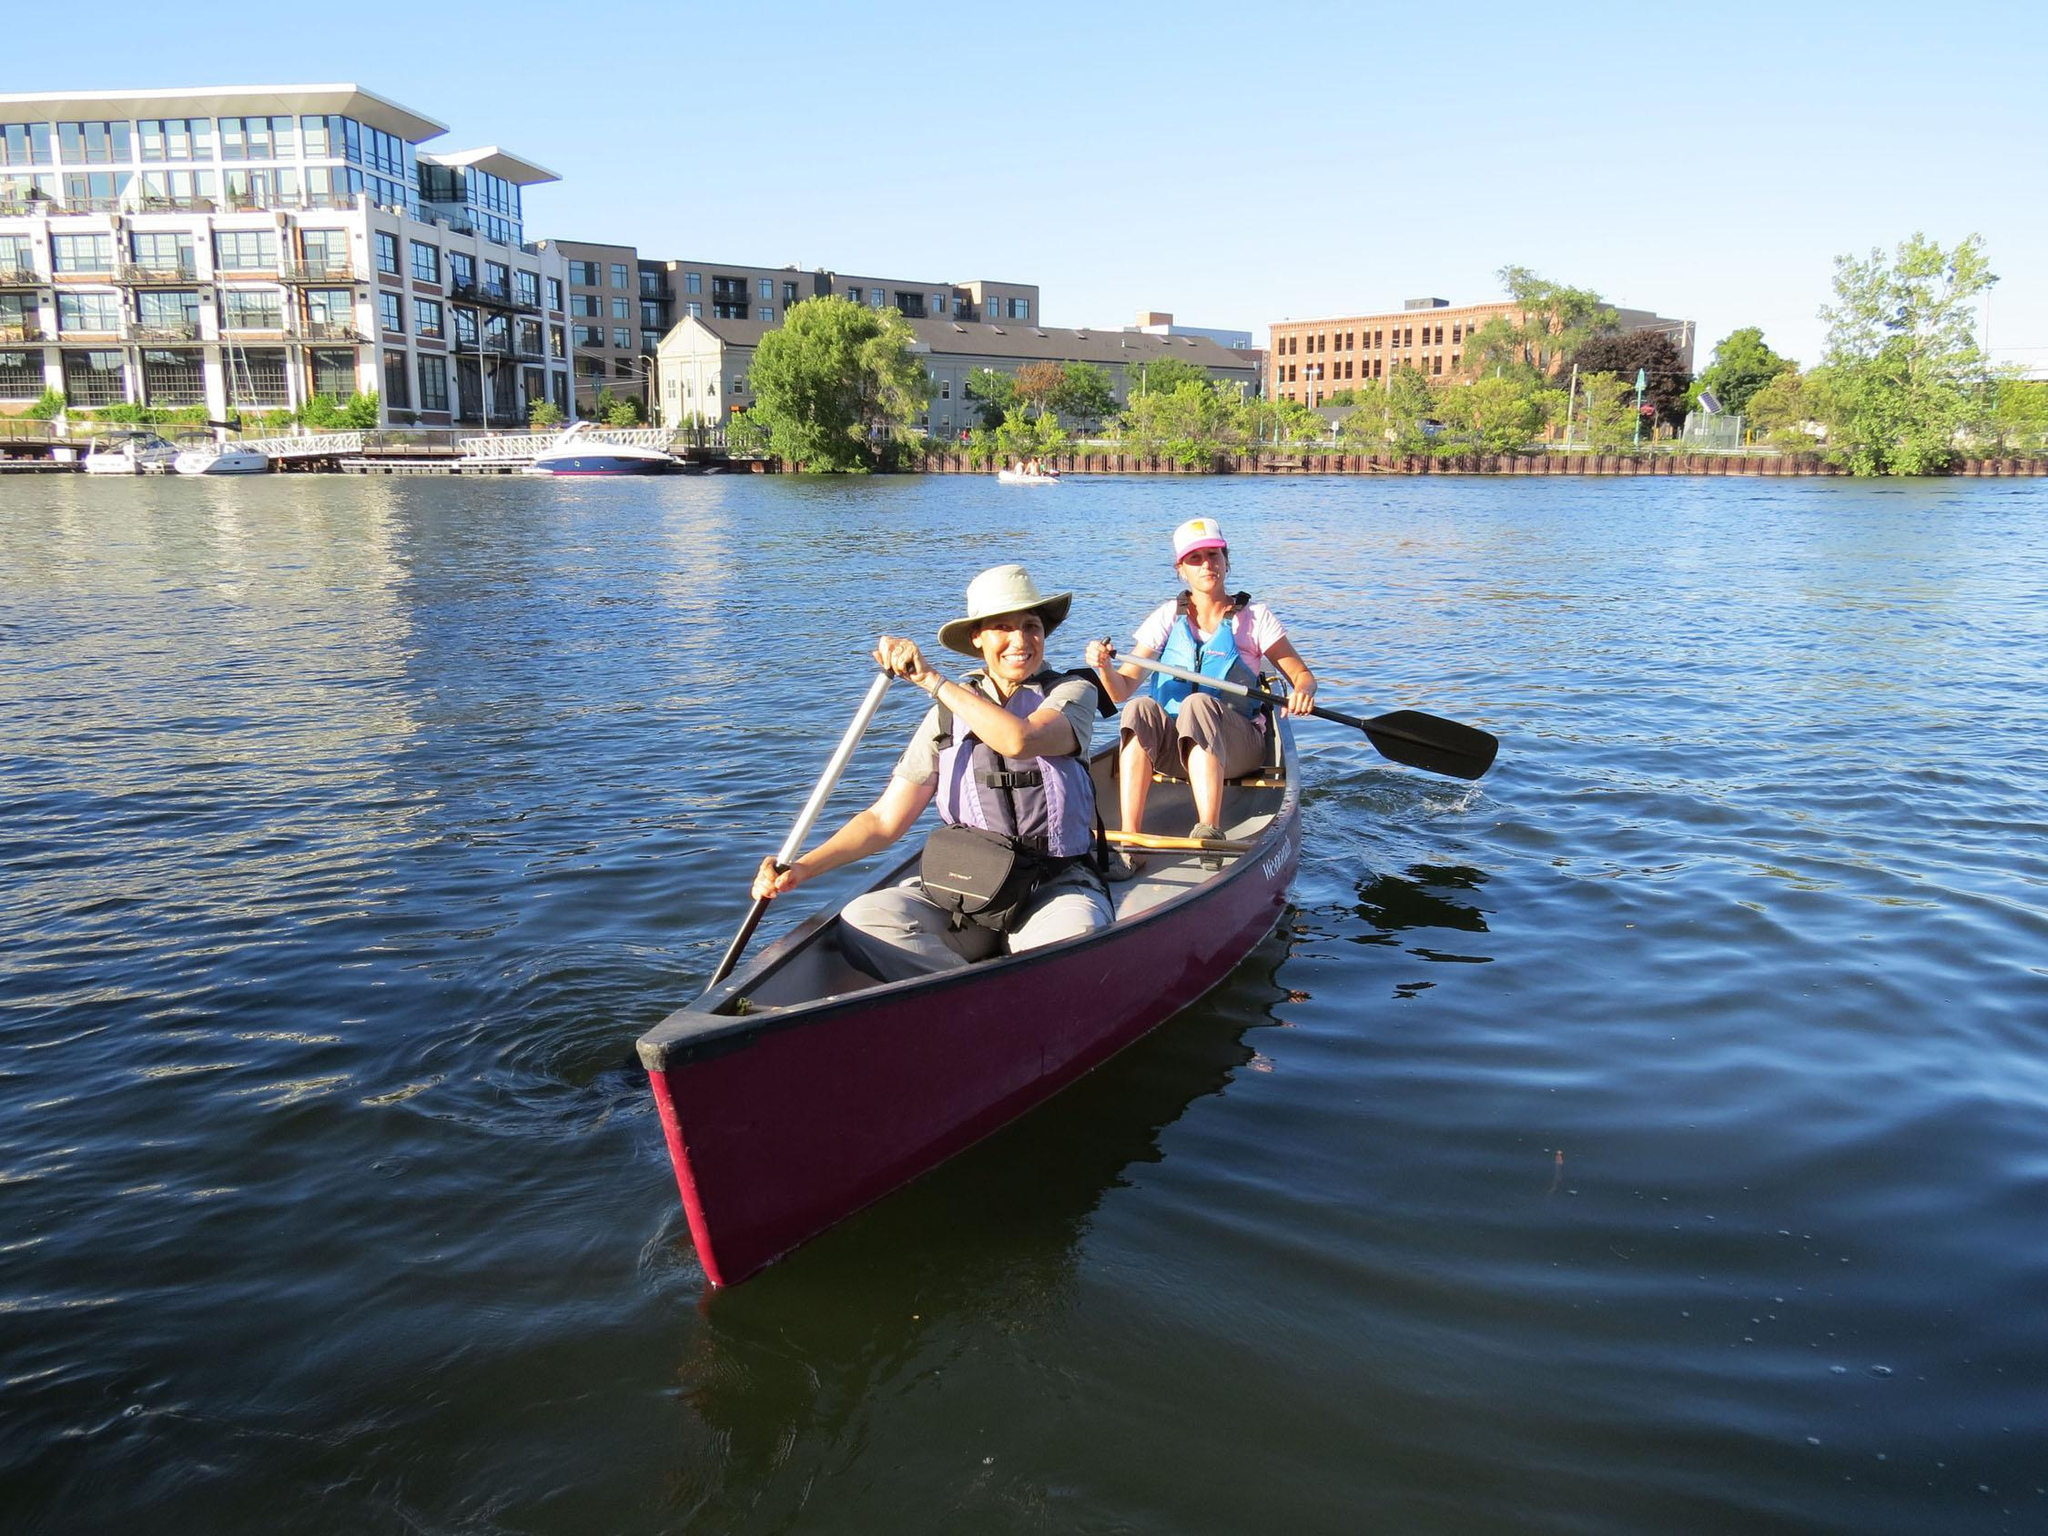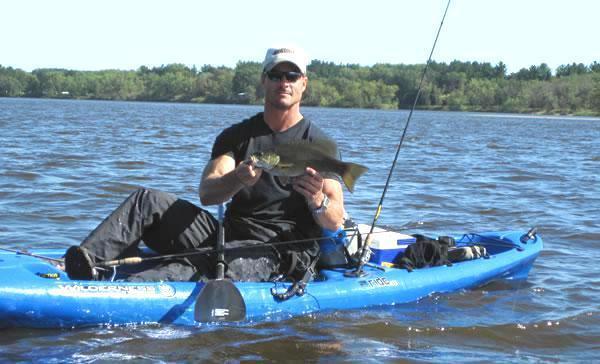The first image is the image on the left, the second image is the image on the right. Given the left and right images, does the statement "There is exactly one boat in the right image." hold true? Answer yes or no. Yes. The first image is the image on the left, the second image is the image on the right. Evaluate the accuracy of this statement regarding the images: "Multiple canoes are moving in one direction on a canal lined with buildings and with a bridge in the background.". Is it true? Answer yes or no. No. 